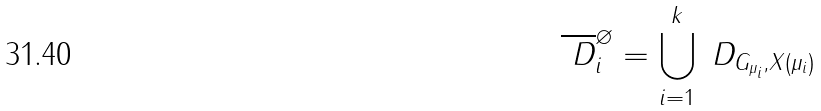<formula> <loc_0><loc_0><loc_500><loc_500>\overline { \ D } ^ { \varnothing } _ { i } = \bigcup _ { i = 1 } ^ { k } \ D _ { G _ { \mu _ { i } } , X ( \mu _ { i } ) }</formula> 